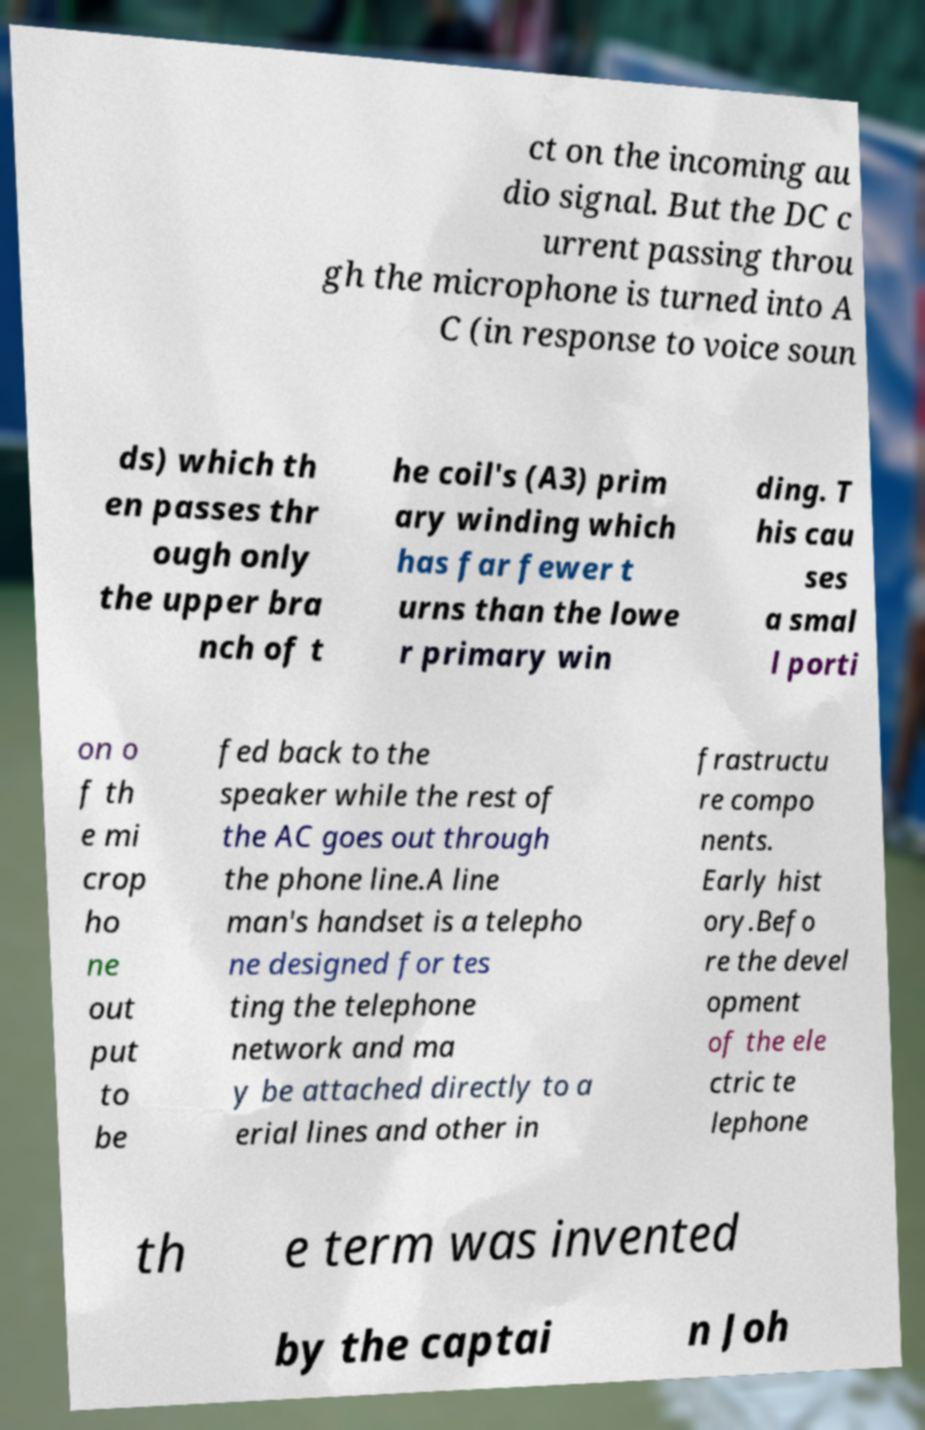I need the written content from this picture converted into text. Can you do that? ct on the incoming au dio signal. But the DC c urrent passing throu gh the microphone is turned into A C (in response to voice soun ds) which th en passes thr ough only the upper bra nch of t he coil's (A3) prim ary winding which has far fewer t urns than the lowe r primary win ding. T his cau ses a smal l porti on o f th e mi crop ho ne out put to be fed back to the speaker while the rest of the AC goes out through the phone line.A line man's handset is a telepho ne designed for tes ting the telephone network and ma y be attached directly to a erial lines and other in frastructu re compo nents. Early hist ory.Befo re the devel opment of the ele ctric te lephone th e term was invented by the captai n Joh 